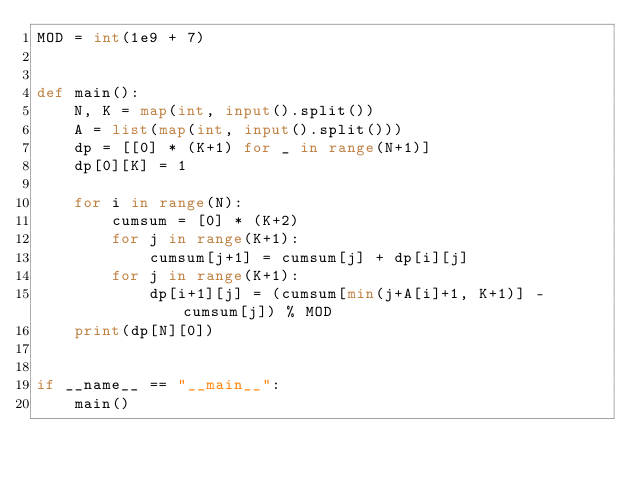Convert code to text. <code><loc_0><loc_0><loc_500><loc_500><_Python_>MOD = int(1e9 + 7)


def main():
    N, K = map(int, input().split())
    A = list(map(int, input().split()))
    dp = [[0] * (K+1) for _ in range(N+1)]
    dp[0][K] = 1

    for i in range(N):
        cumsum = [0] * (K+2)
        for j in range(K+1):
            cumsum[j+1] = cumsum[j] + dp[i][j]
        for j in range(K+1):
            dp[i+1][j] = (cumsum[min(j+A[i]+1, K+1)] - cumsum[j]) % MOD
    print(dp[N][0])


if __name__ == "__main__":
    main()
</code> 